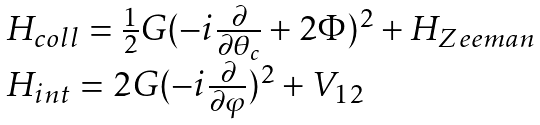Convert formula to latex. <formula><loc_0><loc_0><loc_500><loc_500>\begin{array} { l l l } H _ { c o l l } = \frac { 1 } { 2 } G ( - i \frac { \partial } { \partial \theta _ { c } } + 2 \Phi ) ^ { 2 } + H _ { Z e e m a n } & & \\ H _ { i n t } = 2 G ( - i \frac { \partial } { \partial \varphi } ) ^ { 2 } + V _ { 1 2 } & & \end{array}</formula> 